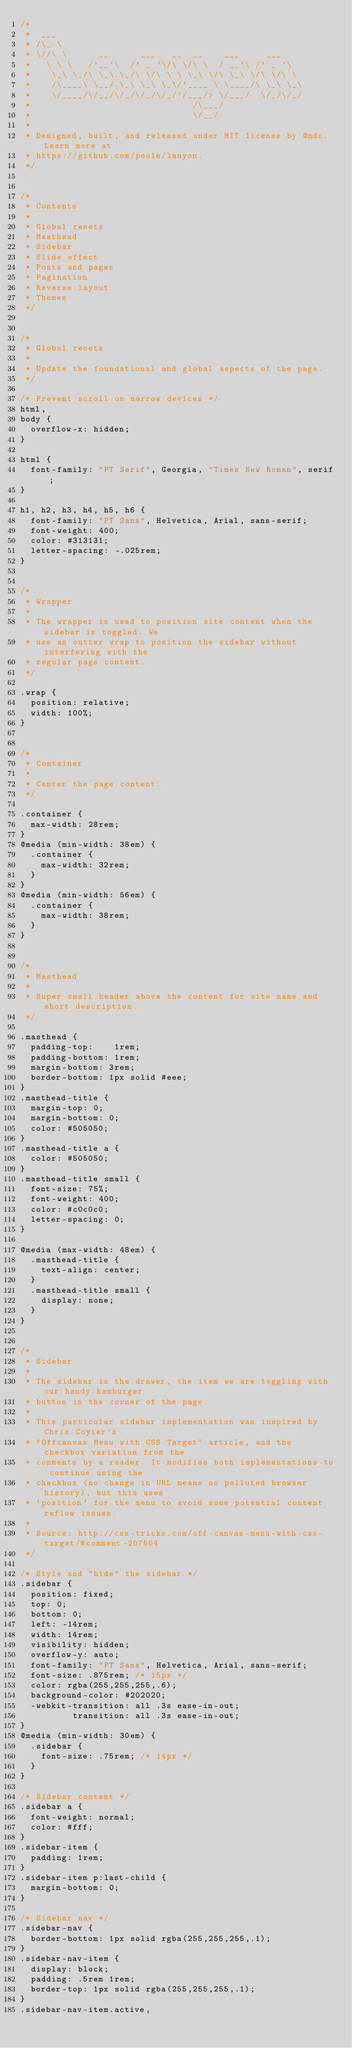Convert code to text. <code><loc_0><loc_0><loc_500><loc_500><_CSS_>/*
 *  ___
 * /\_ \
 * \//\ \      __      ___   __  __    ___     ___
 *   \ \ \   /'__`\  /' _ `\/\ \/\ \  / __`\ /' _ `\
 *    \_\ \_/\ \_\.\_/\ \/\ \ \ \_\ \/\ \_\ \/\ \/\ \
 *    /\____\ \__/.\_\ \_\ \_\/`____ \ \____/\ \_\ \_\
 *    \/____/\/__/\/_/\/_/\/_/`/___/> \/___/  \/_/\/_/
 *                               /\___/
 *                               \/__/
 *
 * Designed, built, and released under MIT license by @mdo. Learn more at
 * https://github.com/poole/lanyon.
 */


/*
 * Contents
 *
 * Global resets
 * Masthead
 * Sidebar
 * Slide effect
 * Posts and pages
 * Pagination
 * Reverse layout
 * Themes
 */


/*
 * Global resets
 *
 * Update the foundational and global aspects of the page.
 */

/* Prevent scroll on narrow devices */
html,
body {
  overflow-x: hidden;
}

html {
  font-family: "PT Serif", Georgia, "Times New Roman", serif;
}

h1, h2, h3, h4, h5, h6 {
  font-family: "PT Sans", Helvetica, Arial, sans-serif;
  font-weight: 400;
  color: #313131;
  letter-spacing: -.025rem;
}


/*
 * Wrapper
 *
 * The wrapper is used to position site content when the sidebar is toggled. We
 * use an outter wrap to position the sidebar without interfering with the
 * regular page content.
 */

.wrap {
  position: relative;
  width: 100%;
}


/*
 * Container
 *
 * Center the page content.
 */

.container {
  max-width: 28rem;
}
@media (min-width: 38em) {
  .container {
    max-width: 32rem;
  }
}
@media (min-width: 56em) {
  .container {
    max-width: 38rem;
  }
}


/*
 * Masthead
 *
 * Super small header above the content for site name and short description.
 */

.masthead {
  padding-top:    1rem;
  padding-bottom: 1rem;
  margin-bottom: 3rem;
  border-bottom: 1px solid #eee;
}
.masthead-title {
  margin-top: 0;
  margin-bottom: 0;
  color: #505050;
}
.masthead-title a {
  color: #505050;
}
.masthead-title small {
  font-size: 75%;
  font-weight: 400;
  color: #c0c0c0;
  letter-spacing: 0;
}

@media (max-width: 48em) {
  .masthead-title {
    text-align: center;
  }
  .masthead-title small {
    display: none;
  }
}


/*
 * Sidebar
 *
 * The sidebar is the drawer, the item we are toggling with our handy hamburger
 * button in the corner of the page.
 *
 * This particular sidebar implementation was inspired by Chris Coyier's
 * "Offcanvas Menu with CSS Target" article, and the checkbox variation from the
 * comments by a reader. It modifies both implementations to continue using the
 * checkbox (no change in URL means no polluted browser history), but this uses
 * `position` for the menu to avoid some potential content reflow issues.
 *
 * Source: http://css-tricks.com/off-canvas-menu-with-css-target/#comment-207504
 */

/* Style and "hide" the sidebar */
.sidebar {
  position: fixed;
  top: 0;
  bottom: 0;
  left: -14rem;
  width: 14rem;
  visibility: hidden;
  overflow-y: auto;
  font-family: "PT Sans", Helvetica, Arial, sans-serif;
  font-size: .875rem; /* 15px */
  color: rgba(255,255,255,.6);
  background-color: #202020;
  -webkit-transition: all .3s ease-in-out;
          transition: all .3s ease-in-out;
}
@media (min-width: 30em) {
  .sidebar {
    font-size: .75rem; /* 14px */
  }
}

/* Sidebar content */
.sidebar a {
  font-weight: normal;
  color: #fff;
}
.sidebar-item {
  padding: 1rem;
}
.sidebar-item p:last-child {
  margin-bottom: 0;
}

/* Sidebar nav */
.sidebar-nav {
  border-bottom: 1px solid rgba(255,255,255,.1);
}
.sidebar-nav-item {
  display: block;
  padding: .5rem 1rem;
  border-top: 1px solid rgba(255,255,255,.1);
}
.sidebar-nav-item.active,</code> 